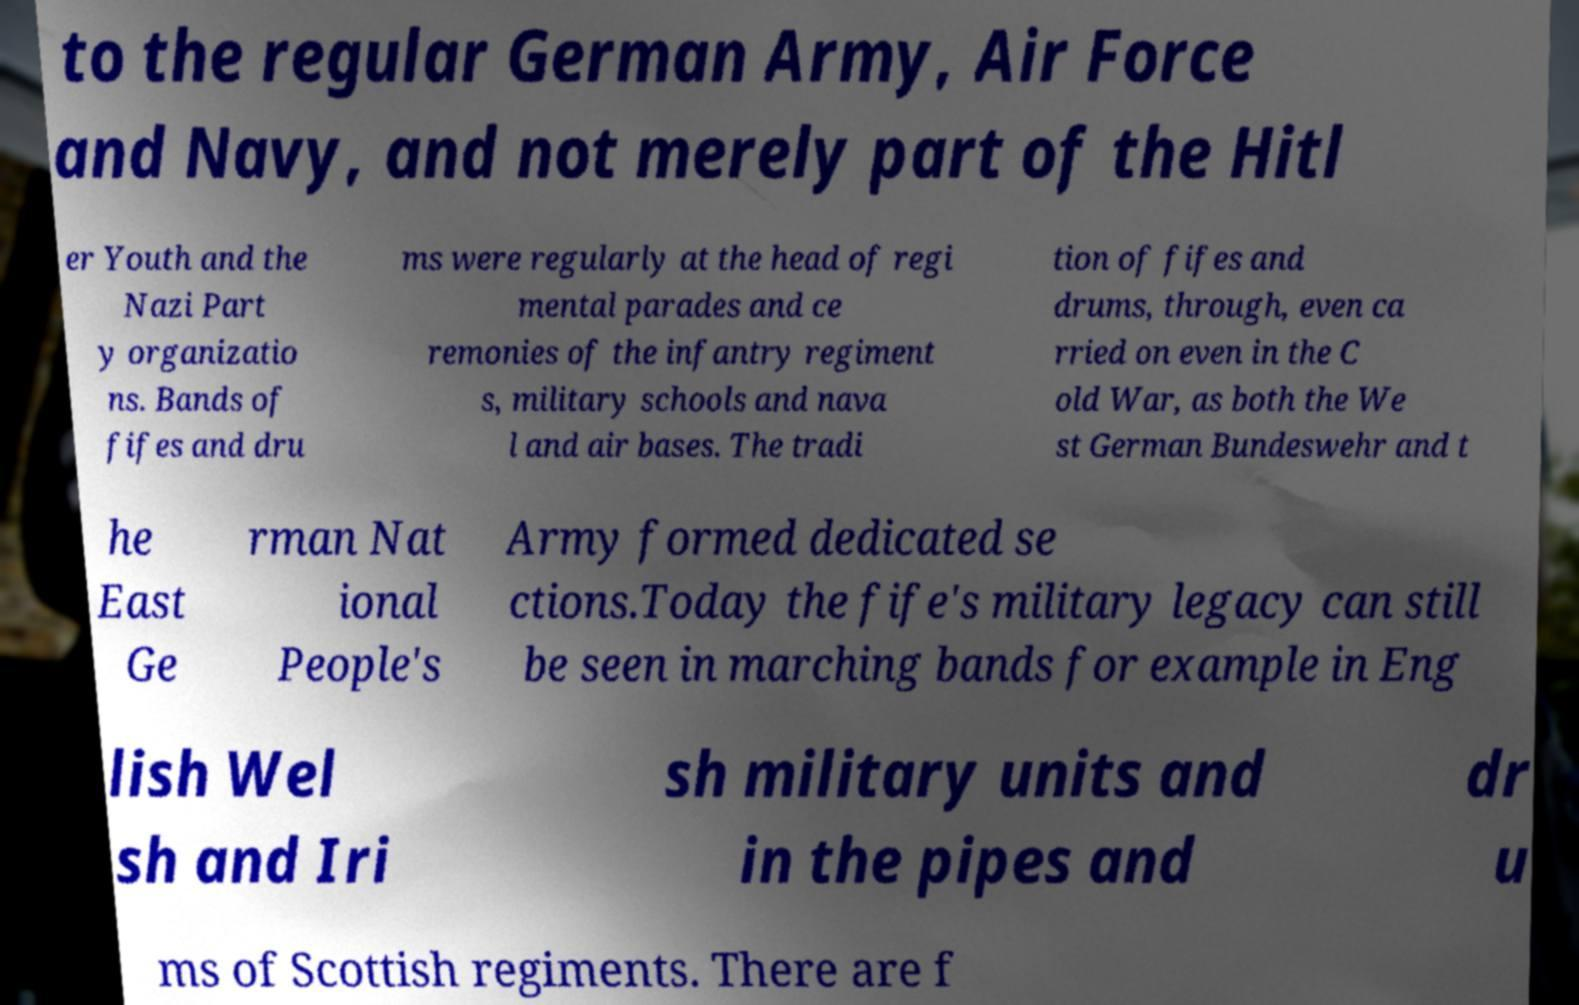Can you read and provide the text displayed in the image?This photo seems to have some interesting text. Can you extract and type it out for me? to the regular German Army, Air Force and Navy, and not merely part of the Hitl er Youth and the Nazi Part y organizatio ns. Bands of fifes and dru ms were regularly at the head of regi mental parades and ce remonies of the infantry regiment s, military schools and nava l and air bases. The tradi tion of fifes and drums, through, even ca rried on even in the C old War, as both the We st German Bundeswehr and t he East Ge rman Nat ional People's Army formed dedicated se ctions.Today the fife's military legacy can still be seen in marching bands for example in Eng lish Wel sh and Iri sh military units and in the pipes and dr u ms of Scottish regiments. There are f 